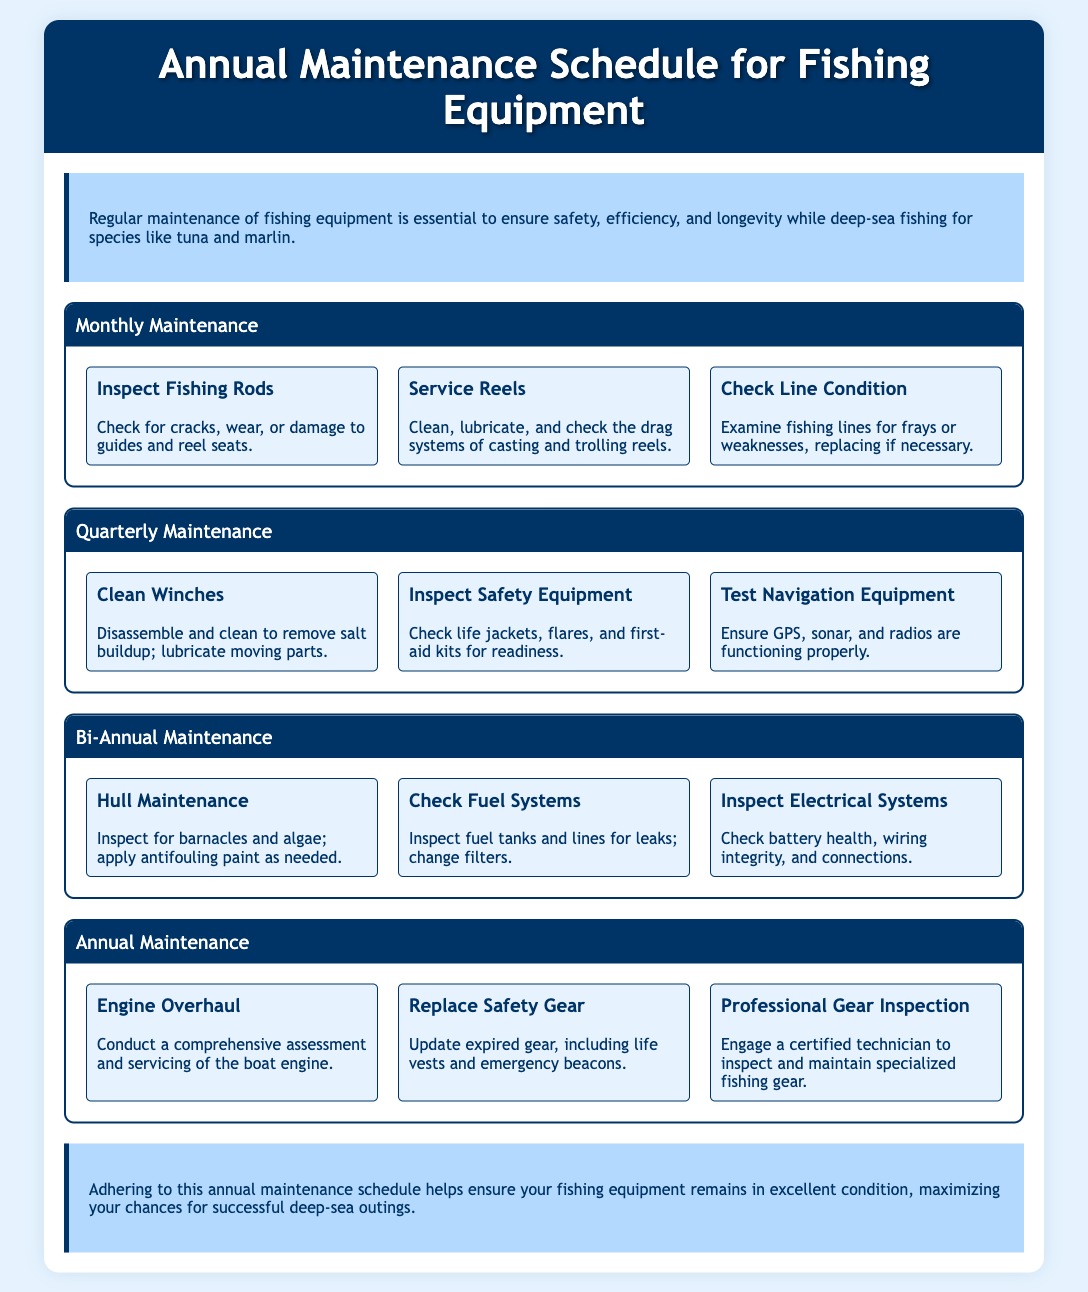what is the title of the document? The title of the document is located in the header section, which provides a clear indication of the content.
Answer: Annual Maintenance Schedule for Fishing Equipment how often should fishing rods be inspected? The frequency of the inspection is indicated in the maintenance section outlining the monthly tasks.
Answer: Monthly what are the tasks included in quarterly maintenance? The document lists specific maintenance tasks under the quarterly section, providing a clear summary of necessary actions to take.
Answer: Clean Winches, Inspect Safety Equipment, Test Navigation Equipment how many tasks are listed under bi-annual maintenance? The number of tasks can be counted from the section dedicated to bi-annual maintenance.
Answer: 3 what is the first task of annual maintenance? The first task listed in the annual maintenance section is the initial action required for engine care.
Answer: Engine Overhaul which equipment should be checked for leaks during maintenance? The specific equipment needing inspection for leaks is mentioned in the bi-annual maintenance tasks.
Answer: Fuel systems what is the purpose of monthly maintenance? The introduction outlines the purpose of regular maintenance in relation to safety and efficiency for fishing equipment.
Answer: Ensure safety, efficiency, and longevity who should perform the professional gear inspection? The document specifies the type of professional responsible for gear inspection under the annual maintenance section.
Answer: Certified technician what action should be taken with expired safety gear? The annual maintenance section states what needs to be done regarding outdated gear.
Answer: Replace 